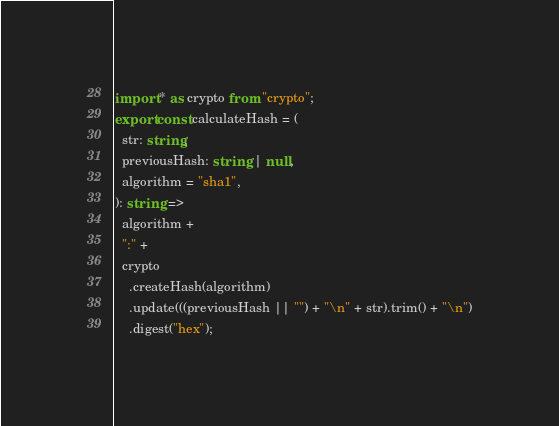Convert code to text. <code><loc_0><loc_0><loc_500><loc_500><_TypeScript_>import * as crypto from "crypto";
export const calculateHash = (
  str: string,
  previousHash: string | null,
  algorithm = "sha1",
): string =>
  algorithm +
  ":" +
  crypto
    .createHash(algorithm)
    .update(((previousHash || "") + "\n" + str).trim() + "\n")
    .digest("hex");
</code> 